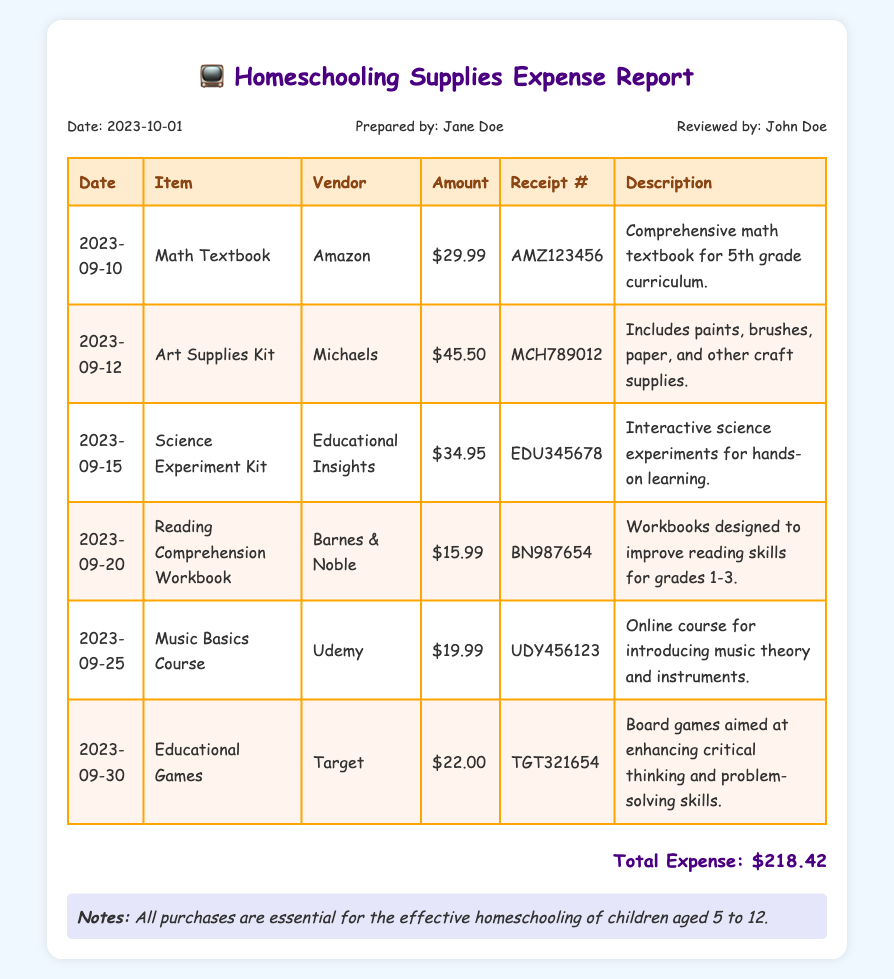What is the date of the expense report? The date of the expense report is found in the header section of the document.
Answer: 2023-10-01 Who prepared the expense report? The name of the person who prepared the report is also located in the header section.
Answer: Jane Doe What is the total amount of expenses reported? The total expenses reported is stated at the end of the table section.
Answer: $218.42 Which vendor supplied the Math Textbook? The vendor information for the Math Textbook is in the corresponding row of the table.
Answer: Amazon What type of materials are included in the Art Supplies Kit? The description of the Art Supplies Kit mentions the contents included.
Answer: Paints, brushes, paper, and other craft supplies How many items were purchased in total? Count the number of entries in the table to find the total purchases.
Answer: 6 What was the receipt number for the Science Experiment Kit? The receipt number is mentioned next to the item in the table.
Answer: EDU345678 Which item had the highest purchase amount? By comparing the amounts listed in the table, we can identify the item with the highest price.
Answer: Art Supplies Kit What was the purpose of the Music Basics Course? The description of the Music Basics Course explains its intent.
Answer: Introducing music theory and instruments 